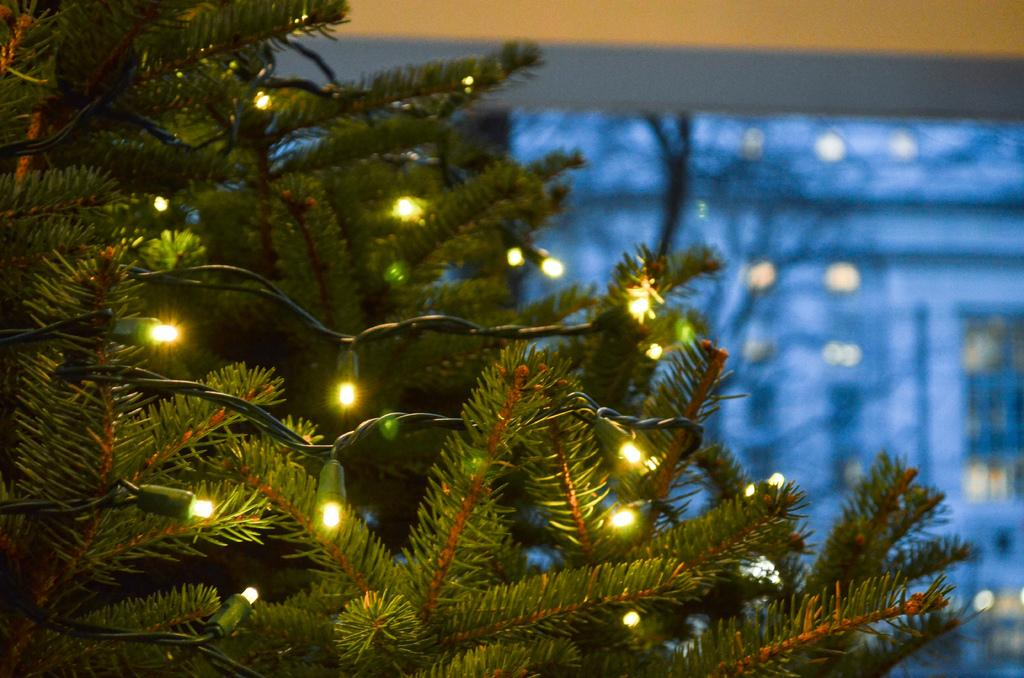What is located at the front of the image? There is a tree in the front of the image. What is attached to the tree? There are lights on the tree. Can you describe the background of the image? The background of the image is blurry. How many cats are sitting on the branches of the tree in the image? There are no cats present in the image; it only features a tree with lights. Are there any dinosaurs visible in the image? There are no dinosaurs present in the image. 